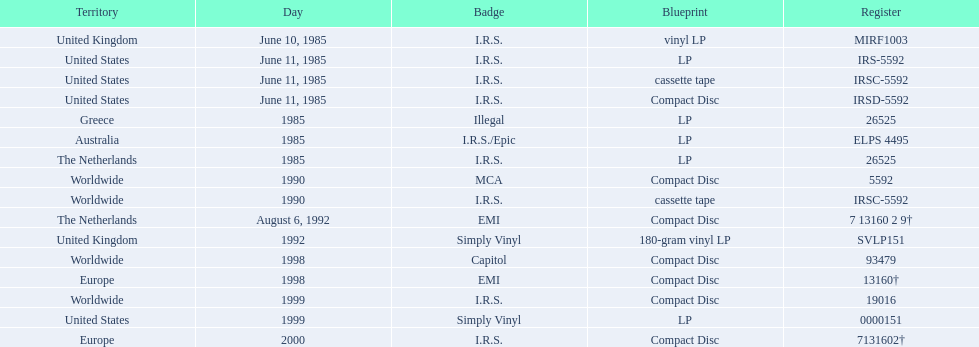Could you parse the entire table as a dict? {'header': ['Territory', 'Day', 'Badge', 'Blueprint', 'Register'], 'rows': [['United Kingdom', 'June 10, 1985', 'I.R.S.', 'vinyl LP', 'MIRF1003'], ['United States', 'June 11, 1985', 'I.R.S.', 'LP', 'IRS-5592'], ['United States', 'June 11, 1985', 'I.R.S.', 'cassette tape', 'IRSC-5592'], ['United States', 'June 11, 1985', 'I.R.S.', 'Compact Disc', 'IRSD-5592'], ['Greece', '1985', 'Illegal', 'LP', '26525'], ['Australia', '1985', 'I.R.S./Epic', 'LP', 'ELPS 4495'], ['The Netherlands', '1985', 'I.R.S.', 'LP', '26525'], ['Worldwide', '1990', 'MCA', 'Compact Disc', '5592'], ['Worldwide', '1990', 'I.R.S.', 'cassette tape', 'IRSC-5592'], ['The Netherlands', 'August 6, 1992', 'EMI', 'Compact Disc', '7 13160 2 9†'], ['United Kingdom', '1992', 'Simply Vinyl', '180-gram vinyl LP', 'SVLP151'], ['Worldwide', '1998', 'Capitol', 'Compact Disc', '93479'], ['Europe', '1998', 'EMI', 'Compact Disc', '13160†'], ['Worldwide', '1999', 'I.R.S.', 'Compact Disc', '19016'], ['United States', '1999', 'Simply Vinyl', 'LP', '0000151'], ['Europe', '2000', 'I.R.S.', 'Compact Disc', '7131602†']]} Which region has more than one format? United States. 